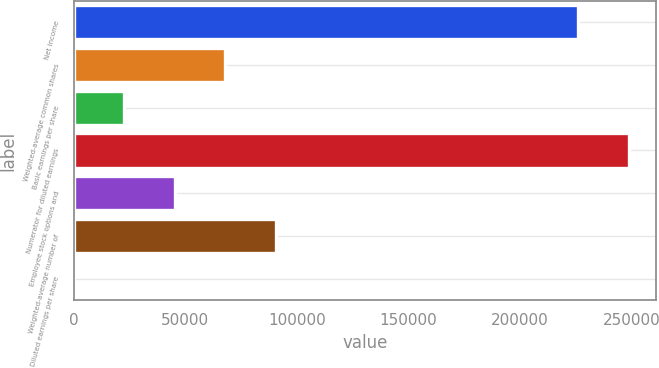<chart> <loc_0><loc_0><loc_500><loc_500><bar_chart><fcel>Net income<fcel>Weighted-average common shares<fcel>Basic earnings per share<fcel>Numerator for diluted earnings<fcel>Employee stock options and<fcel>Weighted-average number of<fcel>Diluted earnings per share<nl><fcel>226126<fcel>67845.8<fcel>22618<fcel>248740<fcel>45231.9<fcel>90459.7<fcel>4.16<nl></chart> 